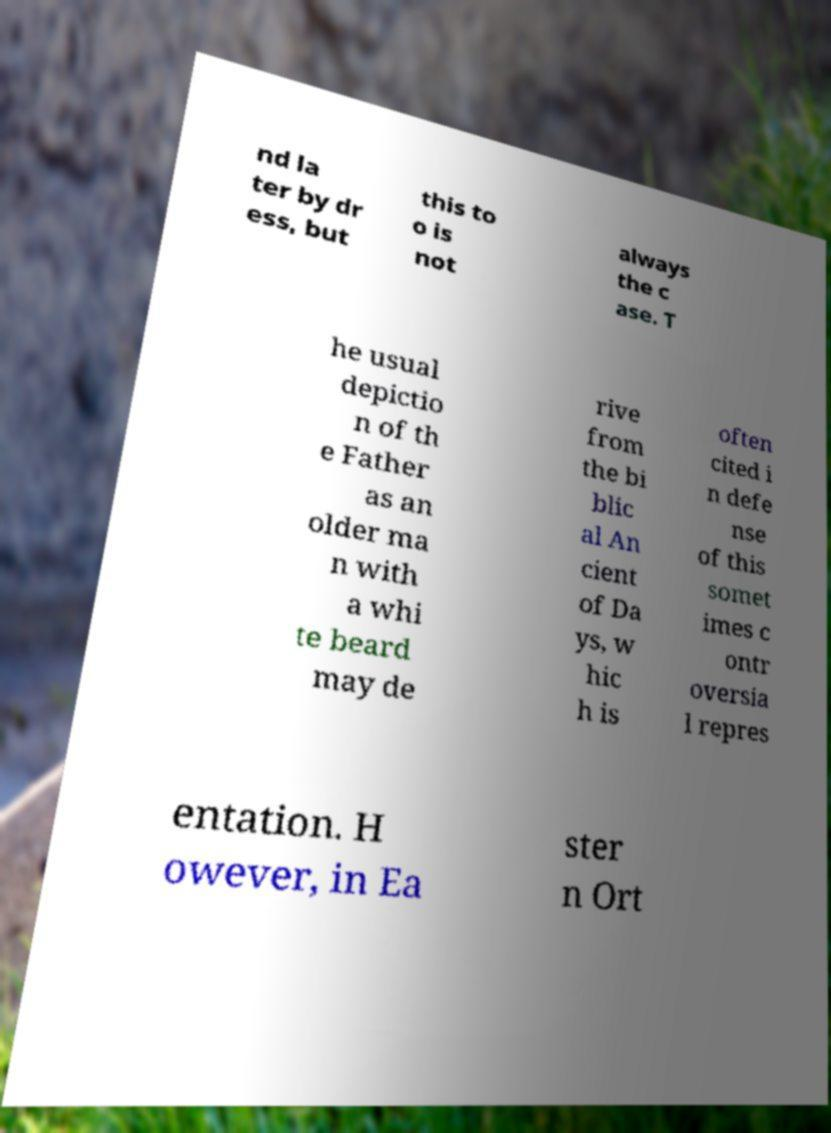Please read and relay the text visible in this image. What does it say? nd la ter by dr ess, but this to o is not always the c ase. T he usual depictio n of th e Father as an older ma n with a whi te beard may de rive from the bi blic al An cient of Da ys, w hic h is often cited i n defe nse of this somet imes c ontr oversia l repres entation. H owever, in Ea ster n Ort 